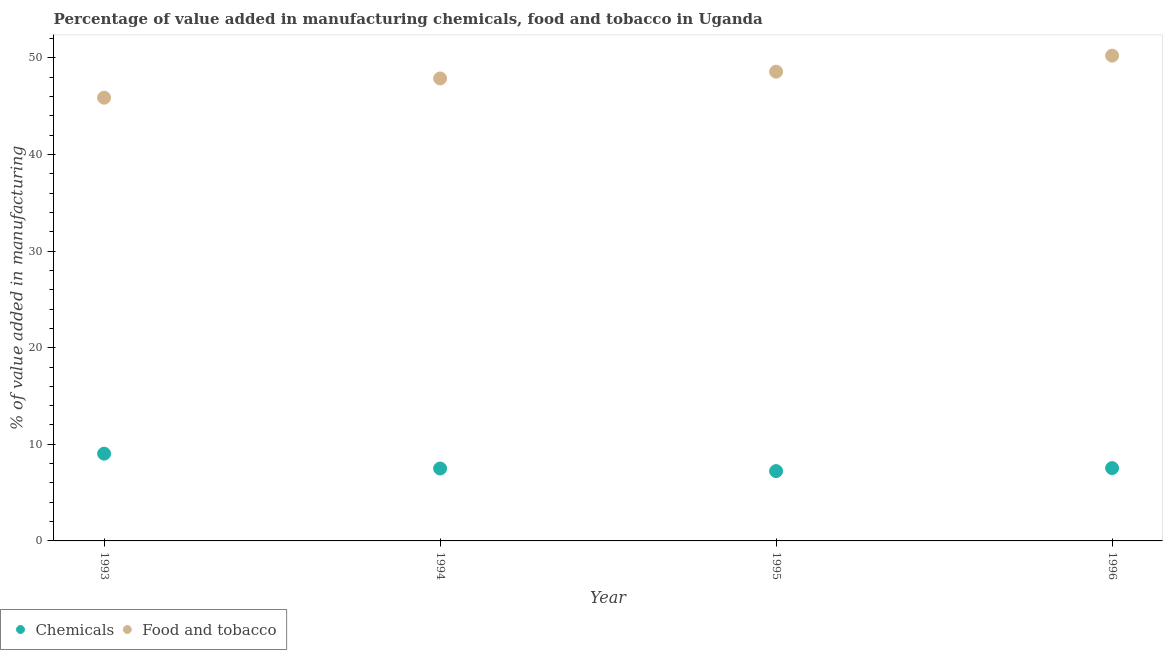What is the value added by manufacturing food and tobacco in 1996?
Ensure brevity in your answer.  50.23. Across all years, what is the maximum value added by  manufacturing chemicals?
Offer a terse response. 9.03. Across all years, what is the minimum value added by manufacturing food and tobacco?
Provide a succinct answer. 45.88. In which year was the value added by manufacturing food and tobacco maximum?
Provide a succinct answer. 1996. In which year was the value added by  manufacturing chemicals minimum?
Your response must be concise. 1995. What is the total value added by manufacturing food and tobacco in the graph?
Your answer should be compact. 192.56. What is the difference between the value added by  manufacturing chemicals in 1994 and that in 1996?
Give a very brief answer. -0.04. What is the difference between the value added by  manufacturing chemicals in 1994 and the value added by manufacturing food and tobacco in 1996?
Make the answer very short. -42.74. What is the average value added by  manufacturing chemicals per year?
Give a very brief answer. 7.82. In the year 1995, what is the difference between the value added by manufacturing food and tobacco and value added by  manufacturing chemicals?
Your response must be concise. 41.35. In how many years, is the value added by  manufacturing chemicals greater than 10 %?
Your answer should be compact. 0. What is the ratio of the value added by manufacturing food and tobacco in 1995 to that in 1996?
Your answer should be very brief. 0.97. Is the value added by  manufacturing chemicals in 1994 less than that in 1996?
Offer a very short reply. Yes. Is the difference between the value added by  manufacturing chemicals in 1994 and 1995 greater than the difference between the value added by manufacturing food and tobacco in 1994 and 1995?
Your response must be concise. Yes. What is the difference between the highest and the second highest value added by  manufacturing chemicals?
Your answer should be compact. 1.5. What is the difference between the highest and the lowest value added by  manufacturing chemicals?
Provide a short and direct response. 1.81. In how many years, is the value added by  manufacturing chemicals greater than the average value added by  manufacturing chemicals taken over all years?
Your answer should be very brief. 1. Is the sum of the value added by manufacturing food and tobacco in 1993 and 1994 greater than the maximum value added by  manufacturing chemicals across all years?
Give a very brief answer. Yes. How many years are there in the graph?
Your response must be concise. 4. Are the values on the major ticks of Y-axis written in scientific E-notation?
Offer a terse response. No. Does the graph contain grids?
Offer a very short reply. No. How many legend labels are there?
Your response must be concise. 2. How are the legend labels stacked?
Offer a very short reply. Horizontal. What is the title of the graph?
Offer a terse response. Percentage of value added in manufacturing chemicals, food and tobacco in Uganda. What is the label or title of the X-axis?
Your response must be concise. Year. What is the label or title of the Y-axis?
Give a very brief answer. % of value added in manufacturing. What is the % of value added in manufacturing of Chemicals in 1993?
Your answer should be very brief. 9.03. What is the % of value added in manufacturing of Food and tobacco in 1993?
Give a very brief answer. 45.88. What is the % of value added in manufacturing in Chemicals in 1994?
Provide a succinct answer. 7.5. What is the % of value added in manufacturing of Food and tobacco in 1994?
Keep it short and to the point. 47.87. What is the % of value added in manufacturing of Chemicals in 1995?
Offer a very short reply. 7.23. What is the % of value added in manufacturing of Food and tobacco in 1995?
Offer a very short reply. 48.57. What is the % of value added in manufacturing in Chemicals in 1996?
Make the answer very short. 7.54. What is the % of value added in manufacturing in Food and tobacco in 1996?
Offer a terse response. 50.23. Across all years, what is the maximum % of value added in manufacturing of Chemicals?
Your response must be concise. 9.03. Across all years, what is the maximum % of value added in manufacturing of Food and tobacco?
Give a very brief answer. 50.23. Across all years, what is the minimum % of value added in manufacturing in Chemicals?
Offer a terse response. 7.23. Across all years, what is the minimum % of value added in manufacturing of Food and tobacco?
Keep it short and to the point. 45.88. What is the total % of value added in manufacturing of Chemicals in the graph?
Your response must be concise. 31.3. What is the total % of value added in manufacturing in Food and tobacco in the graph?
Offer a very short reply. 192.56. What is the difference between the % of value added in manufacturing of Chemicals in 1993 and that in 1994?
Offer a very short reply. 1.54. What is the difference between the % of value added in manufacturing of Food and tobacco in 1993 and that in 1994?
Offer a very short reply. -1.99. What is the difference between the % of value added in manufacturing in Chemicals in 1993 and that in 1995?
Your answer should be compact. 1.81. What is the difference between the % of value added in manufacturing in Food and tobacco in 1993 and that in 1995?
Provide a short and direct response. -2.69. What is the difference between the % of value added in manufacturing of Chemicals in 1993 and that in 1996?
Your response must be concise. 1.5. What is the difference between the % of value added in manufacturing of Food and tobacco in 1993 and that in 1996?
Provide a succinct answer. -4.35. What is the difference between the % of value added in manufacturing of Chemicals in 1994 and that in 1995?
Keep it short and to the point. 0.27. What is the difference between the % of value added in manufacturing in Food and tobacco in 1994 and that in 1995?
Give a very brief answer. -0.7. What is the difference between the % of value added in manufacturing in Chemicals in 1994 and that in 1996?
Offer a very short reply. -0.04. What is the difference between the % of value added in manufacturing of Food and tobacco in 1994 and that in 1996?
Give a very brief answer. -2.36. What is the difference between the % of value added in manufacturing in Chemicals in 1995 and that in 1996?
Your response must be concise. -0.31. What is the difference between the % of value added in manufacturing in Food and tobacco in 1995 and that in 1996?
Your response must be concise. -1.66. What is the difference between the % of value added in manufacturing of Chemicals in 1993 and the % of value added in manufacturing of Food and tobacco in 1994?
Offer a very short reply. -38.84. What is the difference between the % of value added in manufacturing of Chemicals in 1993 and the % of value added in manufacturing of Food and tobacco in 1995?
Ensure brevity in your answer.  -39.54. What is the difference between the % of value added in manufacturing in Chemicals in 1993 and the % of value added in manufacturing in Food and tobacco in 1996?
Offer a terse response. -41.2. What is the difference between the % of value added in manufacturing of Chemicals in 1994 and the % of value added in manufacturing of Food and tobacco in 1995?
Make the answer very short. -41.08. What is the difference between the % of value added in manufacturing in Chemicals in 1994 and the % of value added in manufacturing in Food and tobacco in 1996?
Ensure brevity in your answer.  -42.74. What is the difference between the % of value added in manufacturing in Chemicals in 1995 and the % of value added in manufacturing in Food and tobacco in 1996?
Offer a terse response. -43.01. What is the average % of value added in manufacturing of Chemicals per year?
Offer a very short reply. 7.82. What is the average % of value added in manufacturing of Food and tobacco per year?
Ensure brevity in your answer.  48.14. In the year 1993, what is the difference between the % of value added in manufacturing in Chemicals and % of value added in manufacturing in Food and tobacco?
Keep it short and to the point. -36.85. In the year 1994, what is the difference between the % of value added in manufacturing in Chemicals and % of value added in manufacturing in Food and tobacco?
Your answer should be compact. -40.38. In the year 1995, what is the difference between the % of value added in manufacturing in Chemicals and % of value added in manufacturing in Food and tobacco?
Your answer should be compact. -41.35. In the year 1996, what is the difference between the % of value added in manufacturing in Chemicals and % of value added in manufacturing in Food and tobacco?
Your answer should be very brief. -42.69. What is the ratio of the % of value added in manufacturing of Chemicals in 1993 to that in 1994?
Offer a terse response. 1.21. What is the ratio of the % of value added in manufacturing in Food and tobacco in 1993 to that in 1994?
Provide a short and direct response. 0.96. What is the ratio of the % of value added in manufacturing of Food and tobacco in 1993 to that in 1995?
Keep it short and to the point. 0.94. What is the ratio of the % of value added in manufacturing of Chemicals in 1993 to that in 1996?
Give a very brief answer. 1.2. What is the ratio of the % of value added in manufacturing of Food and tobacco in 1993 to that in 1996?
Keep it short and to the point. 0.91. What is the ratio of the % of value added in manufacturing in Chemicals in 1994 to that in 1995?
Give a very brief answer. 1.04. What is the ratio of the % of value added in manufacturing in Food and tobacco in 1994 to that in 1995?
Give a very brief answer. 0.99. What is the ratio of the % of value added in manufacturing of Food and tobacco in 1994 to that in 1996?
Provide a short and direct response. 0.95. What is the ratio of the % of value added in manufacturing of Chemicals in 1995 to that in 1996?
Ensure brevity in your answer.  0.96. What is the difference between the highest and the second highest % of value added in manufacturing of Chemicals?
Give a very brief answer. 1.5. What is the difference between the highest and the second highest % of value added in manufacturing of Food and tobacco?
Your answer should be compact. 1.66. What is the difference between the highest and the lowest % of value added in manufacturing of Chemicals?
Keep it short and to the point. 1.81. What is the difference between the highest and the lowest % of value added in manufacturing in Food and tobacco?
Your answer should be very brief. 4.35. 